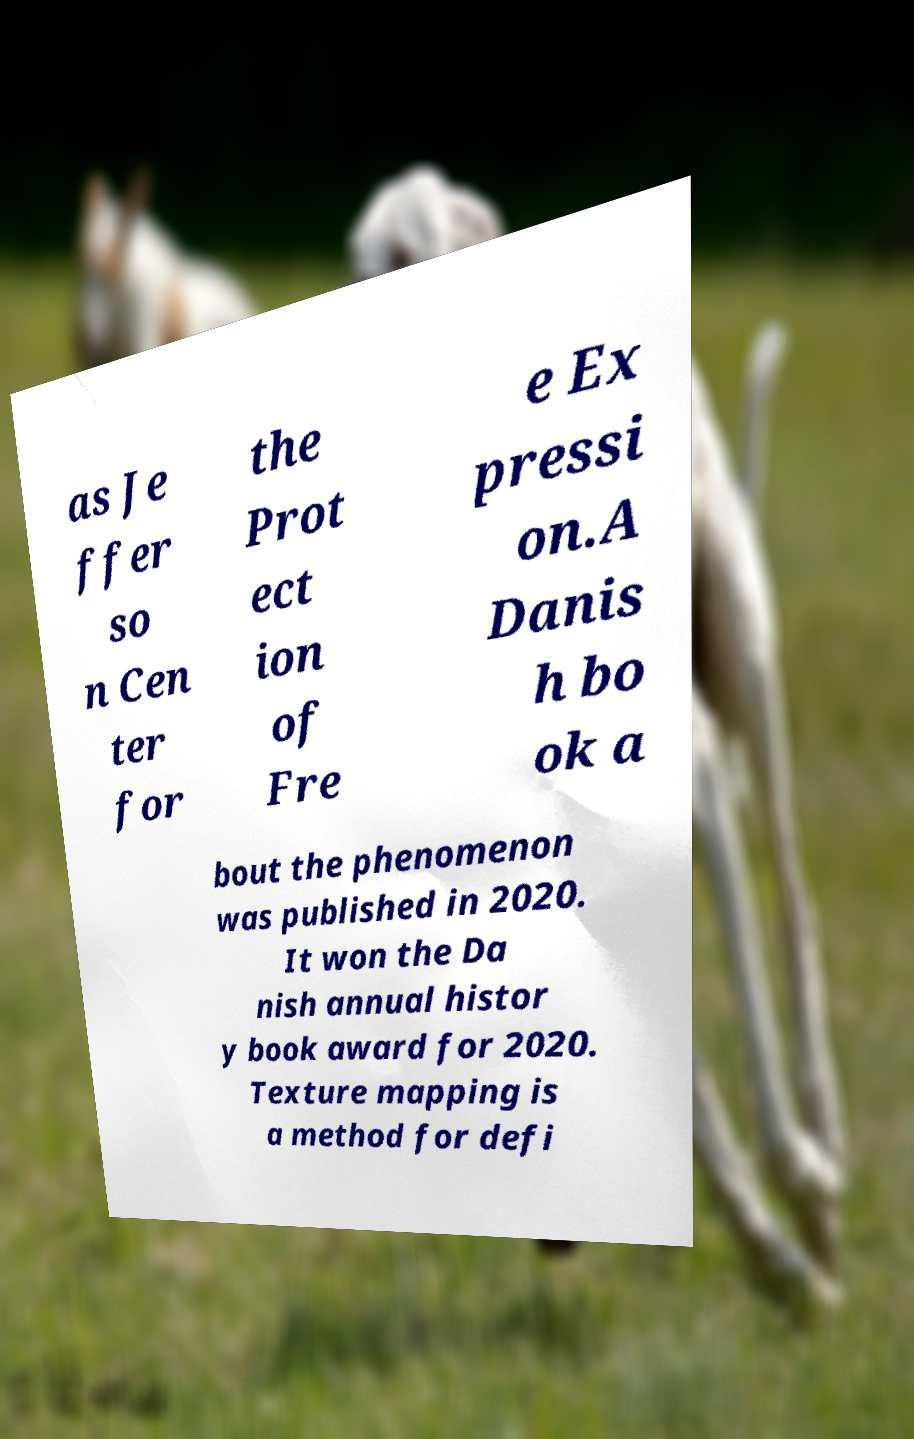Please identify and transcribe the text found in this image. as Je ffer so n Cen ter for the Prot ect ion of Fre e Ex pressi on.A Danis h bo ok a bout the phenomenon was published in 2020. It won the Da nish annual histor y book award for 2020. Texture mapping is a method for defi 